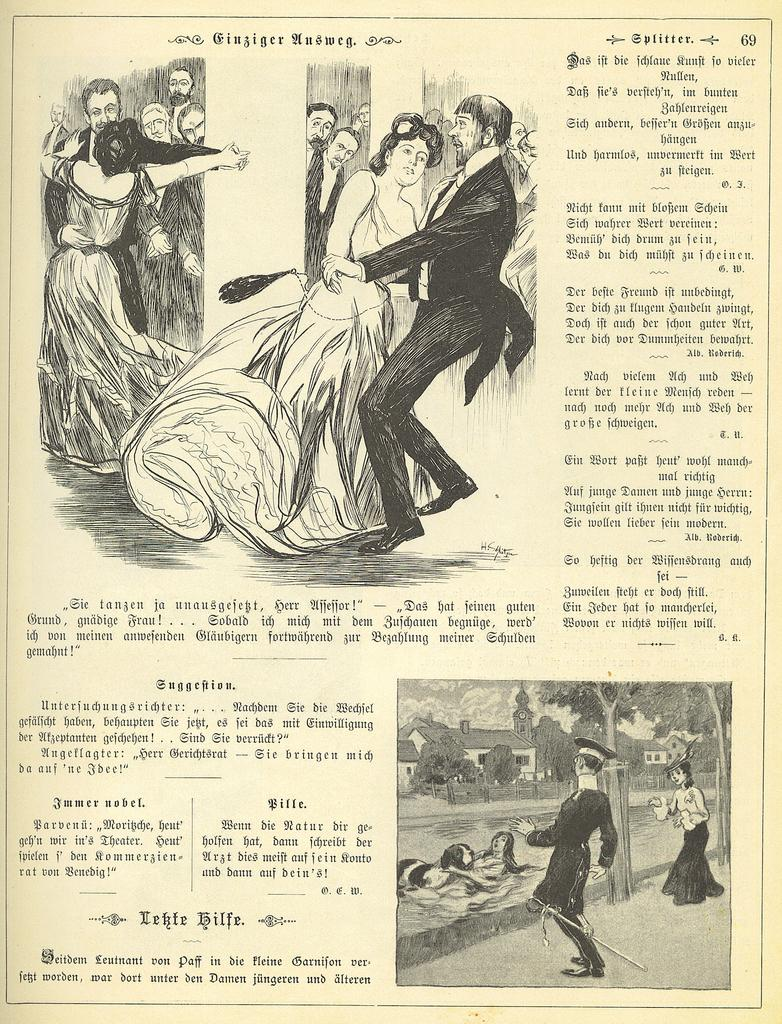What is the main subject in the center of the image? There is a paper in the center of the image. What can be seen on the paper? There are people and objects depicted on the paper, as well as text. What type of quartz can be seen in the image? There is no quartz present in the image; it features a paper with people, objects, and text. What color is the weather in the image? The concept of "color" does not apply to weather, and there is no weather depicted in the image. 